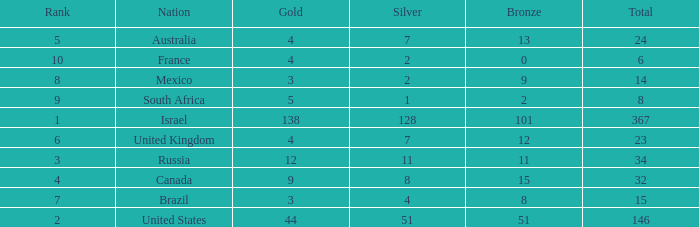What is the gold medal count for the country with a total greater than 32 and more than 128 silvers? None. Could you parse the entire table? {'header': ['Rank', 'Nation', 'Gold', 'Silver', 'Bronze', 'Total'], 'rows': [['5', 'Australia', '4', '7', '13', '24'], ['10', 'France', '4', '2', '0', '6'], ['8', 'Mexico', '3', '2', '9', '14'], ['9', 'South Africa', '5', '1', '2', '8'], ['1', 'Israel', '138', '128', '101', '367'], ['6', 'United Kingdom', '4', '7', '12', '23'], ['3', 'Russia', '12', '11', '11', '34'], ['4', 'Canada', '9', '8', '15', '32'], ['7', 'Brazil', '3', '4', '8', '15'], ['2', 'United States', '44', '51', '51', '146']]} 